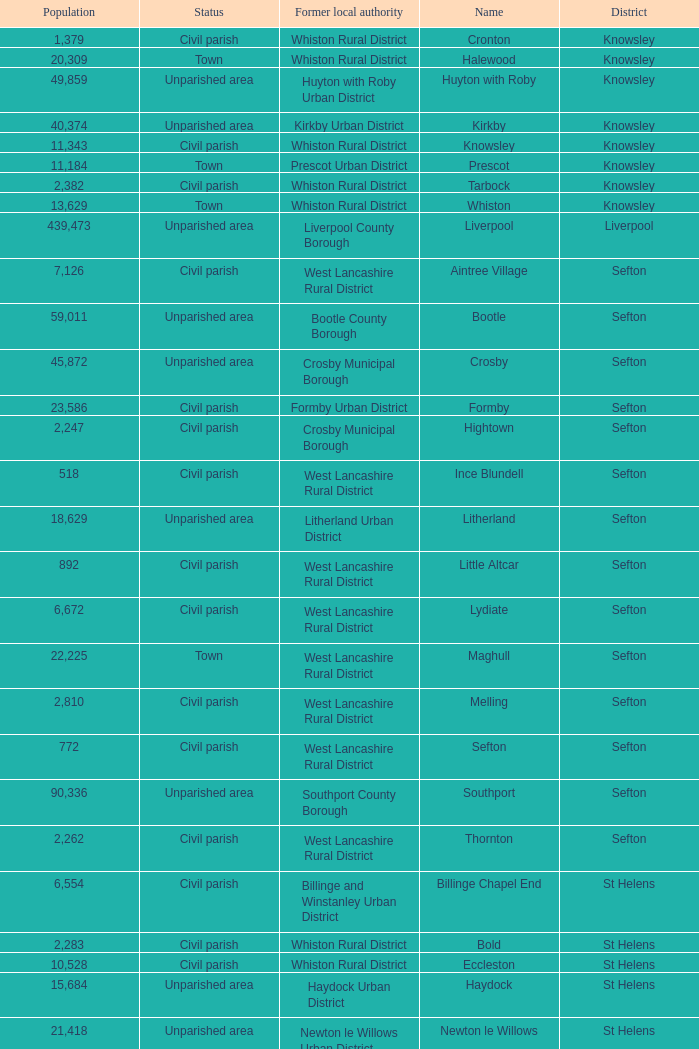What is the district of wallasey Wirral. 